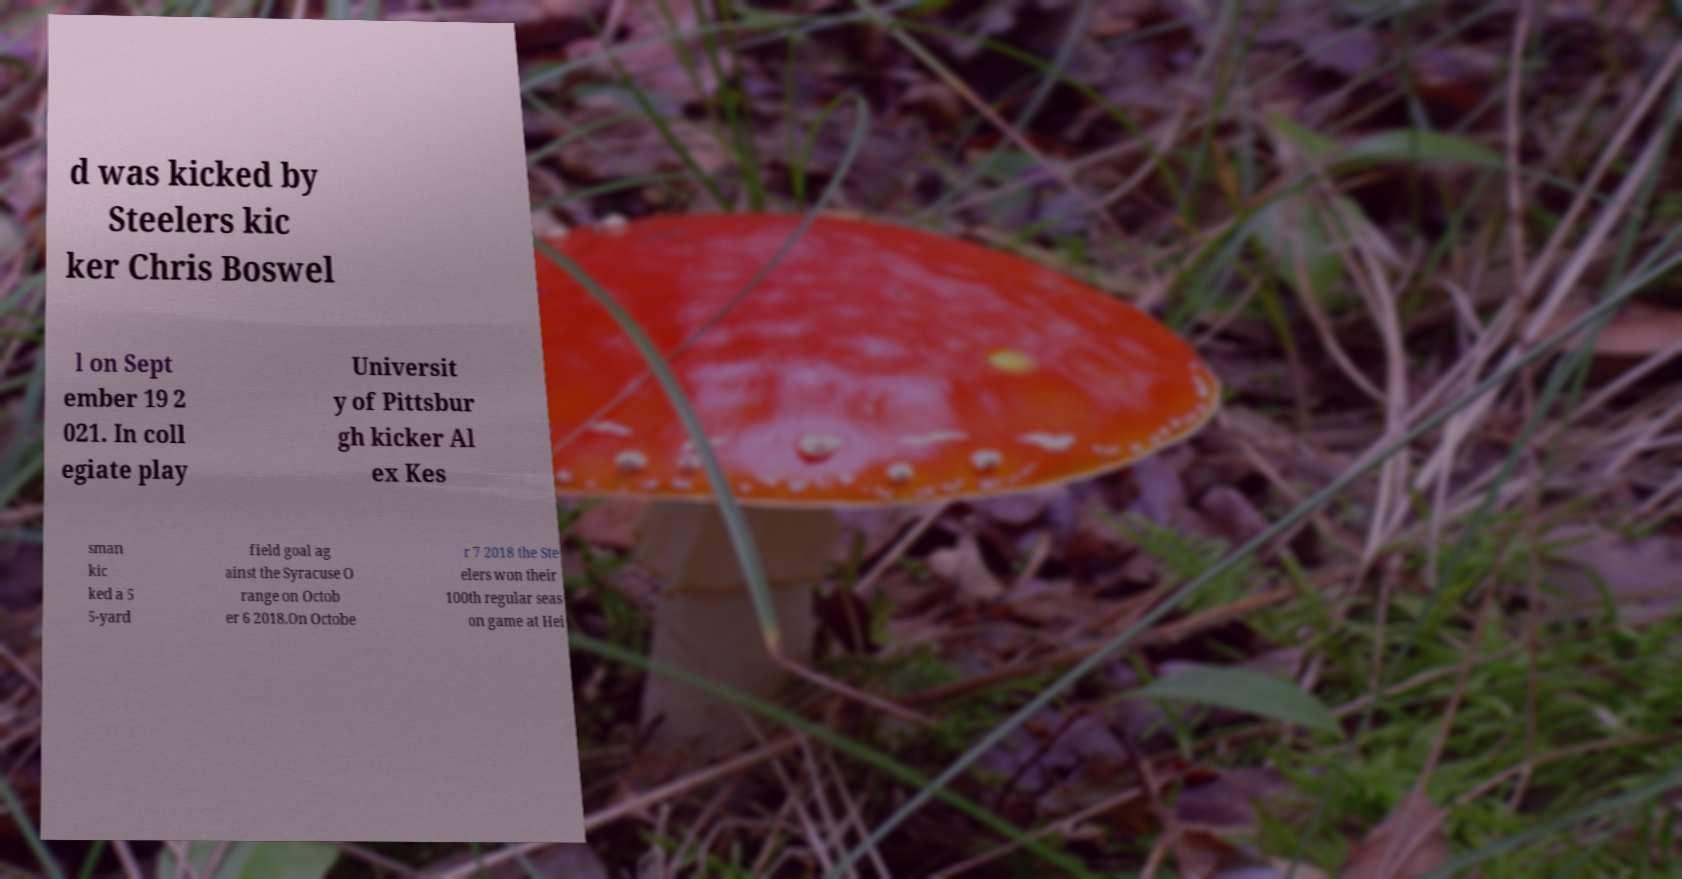I need the written content from this picture converted into text. Can you do that? d was kicked by Steelers kic ker Chris Boswel l on Sept ember 19 2 021. In coll egiate play Universit y of Pittsbur gh kicker Al ex Kes sman kic ked a 5 5-yard field goal ag ainst the Syracuse O range on Octob er 6 2018.On Octobe r 7 2018 the Ste elers won their 100th regular seas on game at Hei 